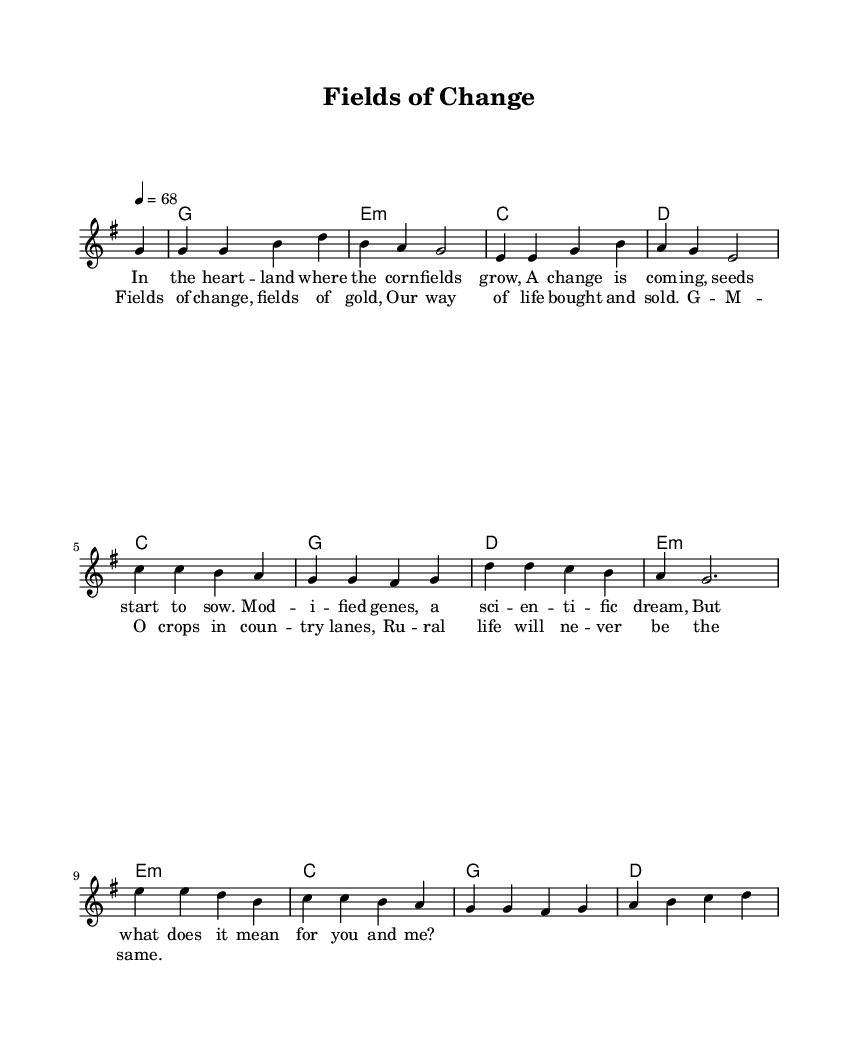What is the key signature of this music? The key signature is G major, which has one sharp (F#). This can be seen on the staff where there is a sharp sign placed on the F line.
Answer: G major What is the time signature? The time signature is 4/4, indicated by the notation at the beginning. This means there are four beats in a measure, and the quarter note gets one beat.
Answer: 4/4 What is the tempo marking of this piece? The tempo marking is 68, which means the piece should be played at 68 beats per minute. This is indicated by the numeric tempo marking at the beginning of the score.
Answer: 68 Identify the type of harmony used in this music. The harmony is based on chord mode, primarily featuring major and minor chords throughout the piece, seen in the chord names under the staff.
Answer: Chord mode How many verses does the song have? The song has one verse followed by a chorus, which consists of the lyrics provided in the score. This coordination can be identified in the structure provided in the score.
Answer: One What themes are addressed in the lyrics? The themes addressed in the lyrics include genetic modification and its impact on rural life, found in the verses that mention "modified genes" and "rural life."
Answer: Genetic modification and rural life 